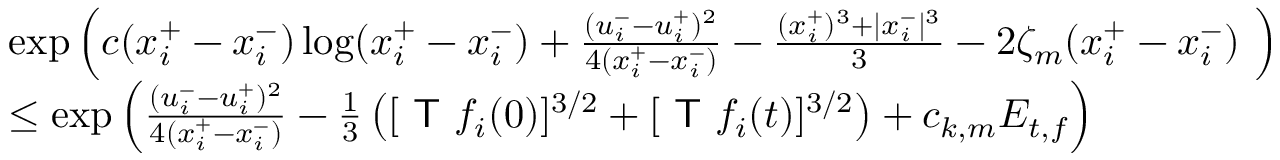<formula> <loc_0><loc_0><loc_500><loc_500>\begin{array} { r l r } & { \exp \left ( c ( x _ { i } ^ { + } - x _ { i } ^ { - } ) \log ( x _ { i } ^ { + } - x _ { i } ^ { - } ) + \frac { ( u _ { i } ^ { - } - u _ { i } ^ { + } ) ^ { 2 } } { 4 ( x _ { i } ^ { + } - x _ { i } ^ { - } ) } - \frac { ( x _ { i } ^ { + } ) ^ { 3 } + | x _ { i } ^ { - } | ^ { 3 } } { 3 } - 2 \zeta _ { m } ( x _ { i } ^ { + } - x _ { i } ^ { - } ) \ \right ) } \\ & { \leq \exp \left ( \frac { ( u _ { i } ^ { - } - u _ { i } ^ { + } ) ^ { 2 } } { 4 ( x _ { i } ^ { + } - x _ { i } ^ { - } ) } - \frac { 1 } { 3 } \left ( [ T f _ { i } ( 0 ) ] ^ { 3 / 2 } + [ T f _ { i } ( t ) ] ^ { 3 / 2 } \right ) + c _ { k , m } E _ { t , f } \right ) } & \end{array}</formula> 